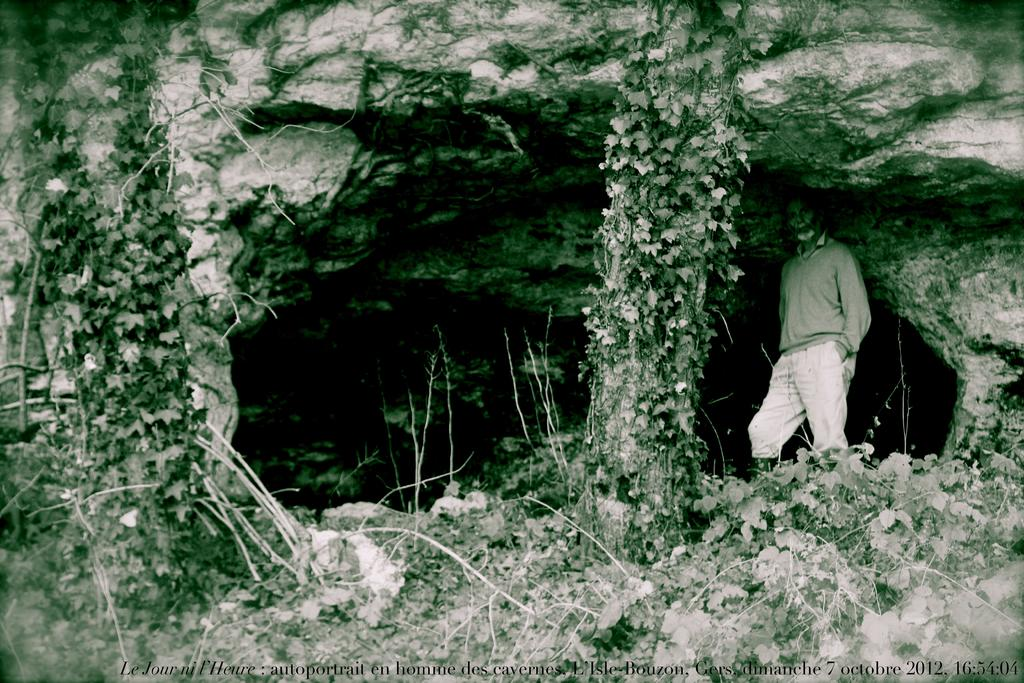What is the main subject of the image? There is a person in the image. What type of natural elements can be seen in the image? There are trees and plants in the image. What type of geological formation is present in the image? There is a cave in the image. What type of instrument is the rabbit playing in the image? There is no rabbit or instrument present in the image. What is the relation between the person and the cave in the image? The provided facts do not mention any relation between the person and the cave; we can only observe their presence in the same image. 